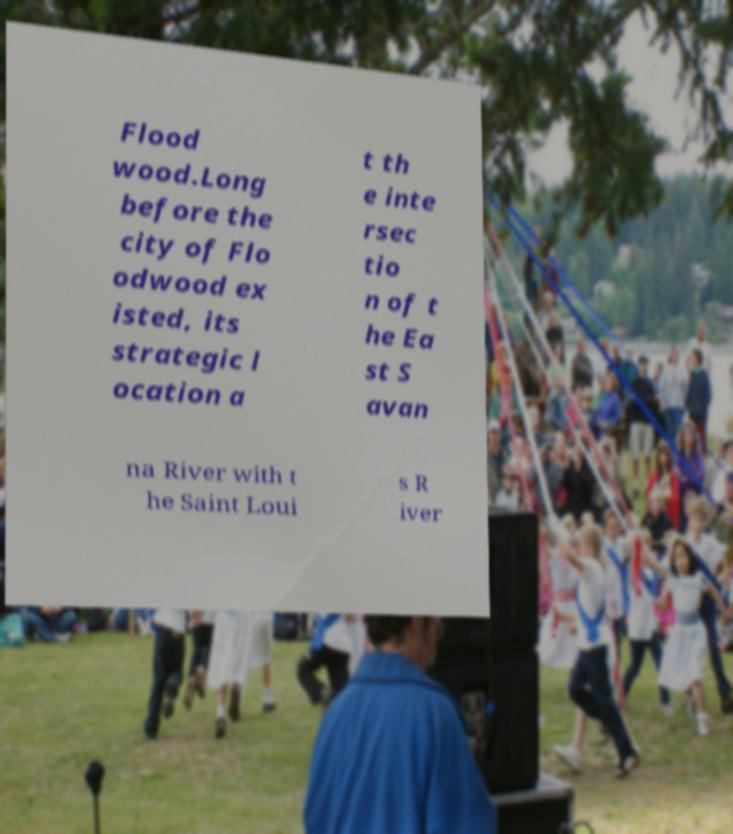I need the written content from this picture converted into text. Can you do that? Flood wood.Long before the city of Flo odwood ex isted, its strategic l ocation a t th e inte rsec tio n of t he Ea st S avan na River with t he Saint Loui s R iver 